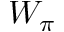<formula> <loc_0><loc_0><loc_500><loc_500>W _ { \pi }</formula> 